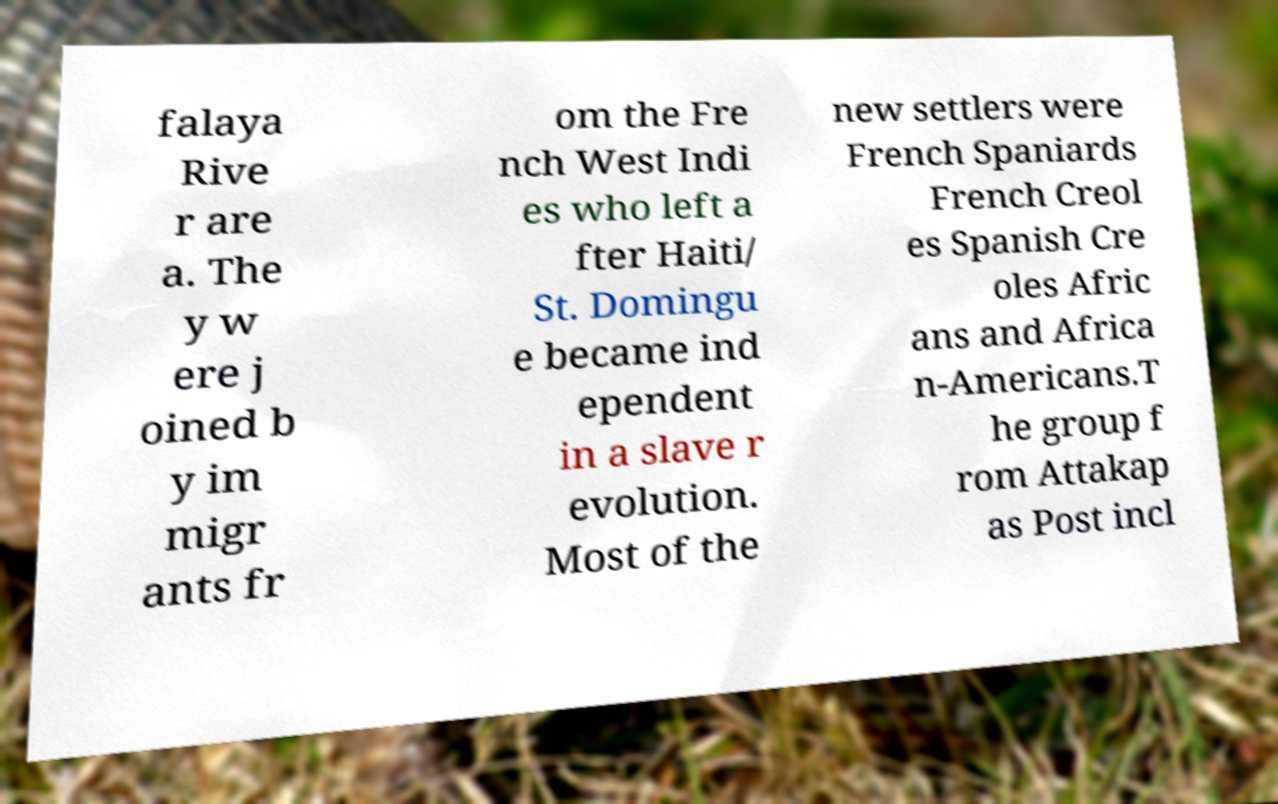I need the written content from this picture converted into text. Can you do that? falaya Rive r are a. The y w ere j oined b y im migr ants fr om the Fre nch West Indi es who left a fter Haiti/ St. Domingu e became ind ependent in a slave r evolution. Most of the new settlers were French Spaniards French Creol es Spanish Cre oles Afric ans and Africa n-Americans.T he group f rom Attakap as Post incl 